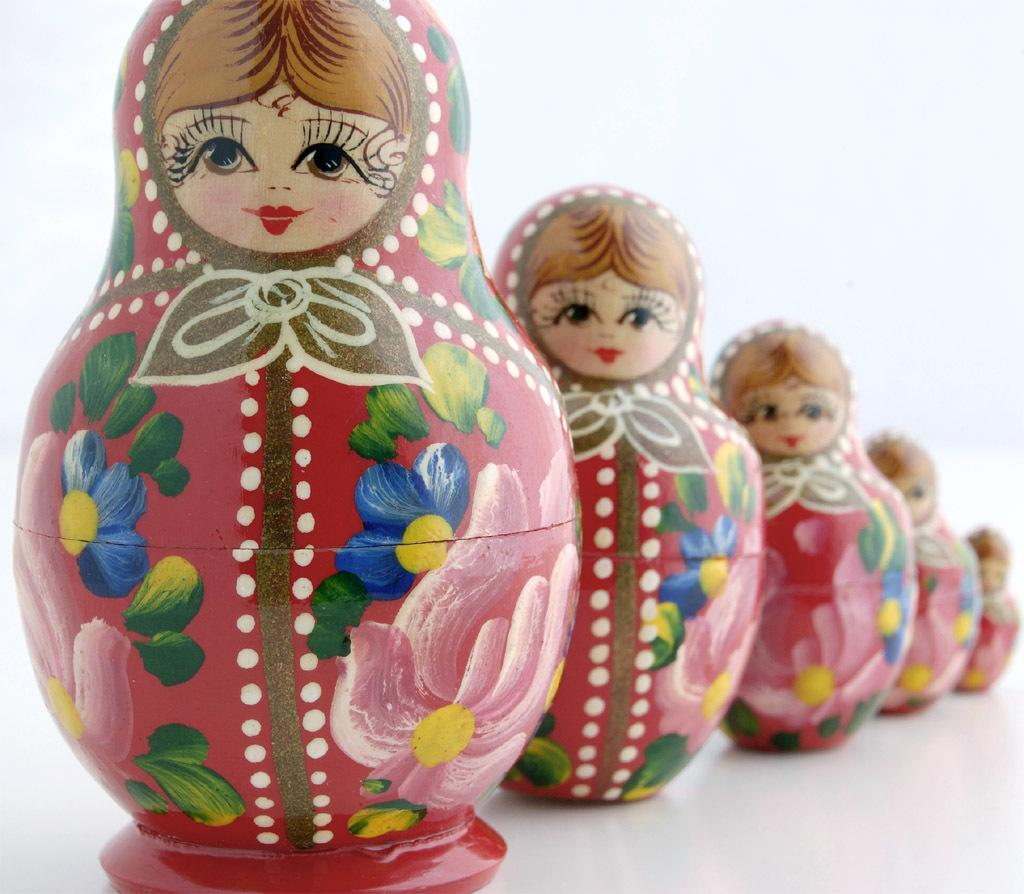How many toys are visible in the image? There are five toys in the image. What can be observed on the surface of the toys? The toys have painted designs on them. What color is the background of the image? The background of the image is white. Reasoning: Let's think step by following the guidelines to produce the conversation. We start by identifying the main subject, which is the toys. We then describe their characteristics, such as the painted designs on them. Finally, we mention the background color. Each question is designed to elicit a specific detail about the image that is known from the provided facts. Absurd Question/Answer: What type of pipe is being used to add more toys to the image? There is no pipe or addition of toys visible in the image; it only shows five toys with painted designs on a white background. 